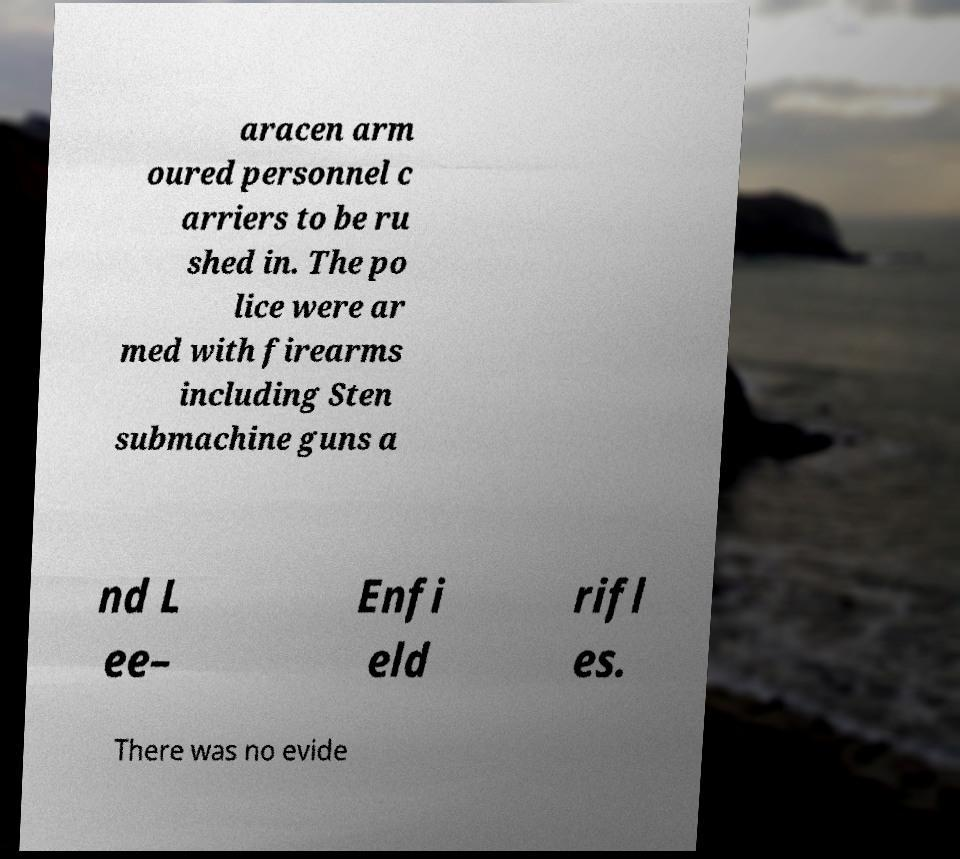Could you extract and type out the text from this image? aracen arm oured personnel c arriers to be ru shed in. The po lice were ar med with firearms including Sten submachine guns a nd L ee– Enfi eld rifl es. There was no evide 